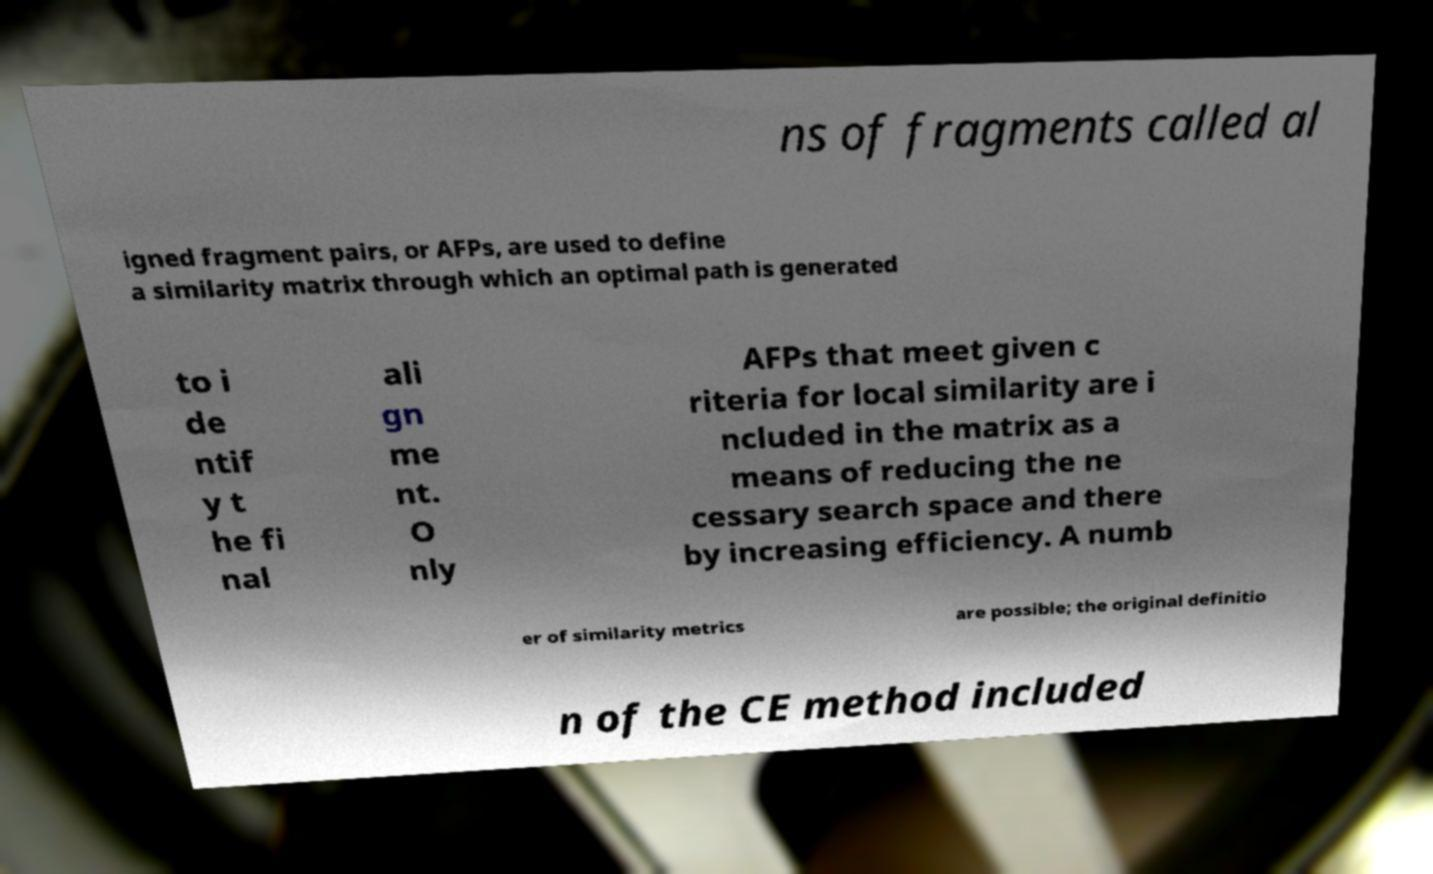What messages or text are displayed in this image? I need them in a readable, typed format. ns of fragments called al igned fragment pairs, or AFPs, are used to define a similarity matrix through which an optimal path is generated to i de ntif y t he fi nal ali gn me nt. O nly AFPs that meet given c riteria for local similarity are i ncluded in the matrix as a means of reducing the ne cessary search space and there by increasing efficiency. A numb er of similarity metrics are possible; the original definitio n of the CE method included 